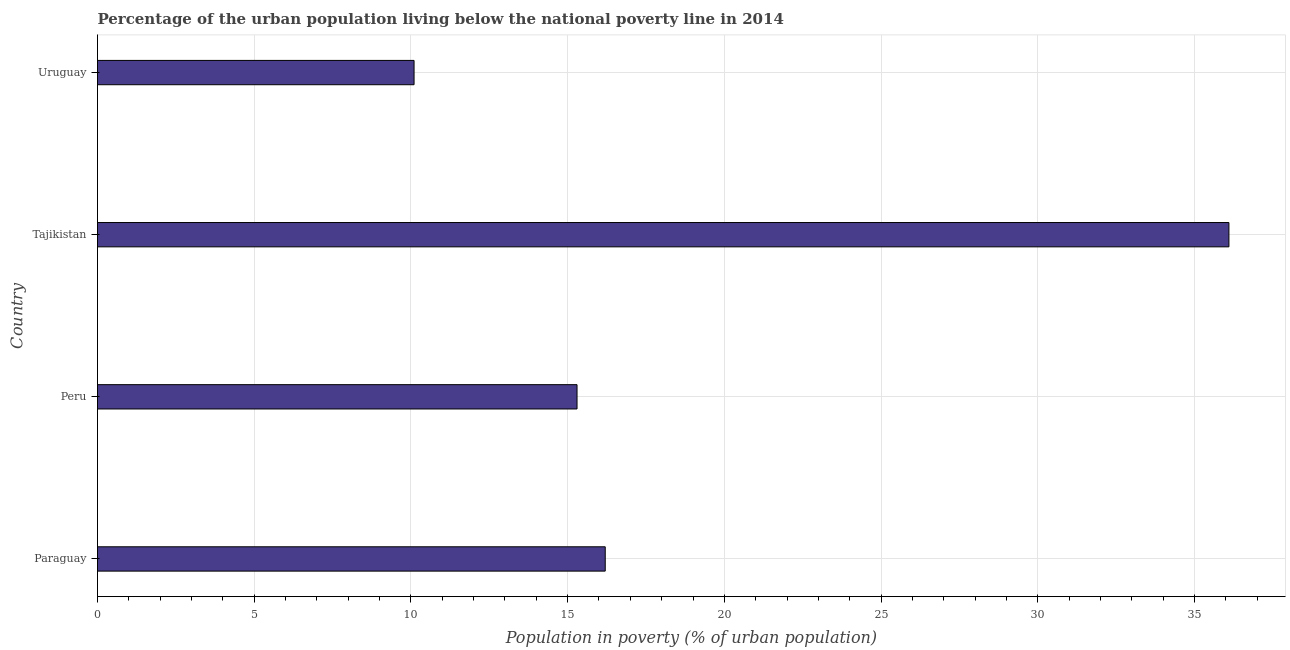Does the graph contain any zero values?
Make the answer very short. No. Does the graph contain grids?
Your answer should be very brief. Yes. What is the title of the graph?
Keep it short and to the point. Percentage of the urban population living below the national poverty line in 2014. What is the label or title of the X-axis?
Provide a succinct answer. Population in poverty (% of urban population). What is the label or title of the Y-axis?
Offer a terse response. Country. Across all countries, what is the maximum percentage of urban population living below poverty line?
Your answer should be very brief. 36.1. In which country was the percentage of urban population living below poverty line maximum?
Your answer should be very brief. Tajikistan. In which country was the percentage of urban population living below poverty line minimum?
Offer a very short reply. Uruguay. What is the sum of the percentage of urban population living below poverty line?
Offer a very short reply. 77.7. What is the difference between the percentage of urban population living below poverty line in Paraguay and Uruguay?
Provide a short and direct response. 6.1. What is the average percentage of urban population living below poverty line per country?
Provide a short and direct response. 19.43. What is the median percentage of urban population living below poverty line?
Provide a short and direct response. 15.75. In how many countries, is the percentage of urban population living below poverty line greater than 21 %?
Your answer should be very brief. 1. What is the ratio of the percentage of urban population living below poverty line in Tajikistan to that in Uruguay?
Keep it short and to the point. 3.57. Is the difference between the percentage of urban population living below poverty line in Paraguay and Uruguay greater than the difference between any two countries?
Offer a very short reply. No. What is the difference between the highest and the second highest percentage of urban population living below poverty line?
Ensure brevity in your answer.  19.9. Is the sum of the percentage of urban population living below poverty line in Tajikistan and Uruguay greater than the maximum percentage of urban population living below poverty line across all countries?
Your response must be concise. Yes. What is the difference between the highest and the lowest percentage of urban population living below poverty line?
Provide a succinct answer. 26. In how many countries, is the percentage of urban population living below poverty line greater than the average percentage of urban population living below poverty line taken over all countries?
Ensure brevity in your answer.  1. How many bars are there?
Your answer should be compact. 4. Are all the bars in the graph horizontal?
Provide a short and direct response. Yes. How many countries are there in the graph?
Provide a succinct answer. 4. Are the values on the major ticks of X-axis written in scientific E-notation?
Keep it short and to the point. No. What is the Population in poverty (% of urban population) of Tajikistan?
Make the answer very short. 36.1. What is the difference between the Population in poverty (% of urban population) in Paraguay and Tajikistan?
Offer a terse response. -19.9. What is the difference between the Population in poverty (% of urban population) in Peru and Tajikistan?
Offer a very short reply. -20.8. What is the ratio of the Population in poverty (% of urban population) in Paraguay to that in Peru?
Make the answer very short. 1.06. What is the ratio of the Population in poverty (% of urban population) in Paraguay to that in Tajikistan?
Your answer should be compact. 0.45. What is the ratio of the Population in poverty (% of urban population) in Paraguay to that in Uruguay?
Offer a terse response. 1.6. What is the ratio of the Population in poverty (% of urban population) in Peru to that in Tajikistan?
Provide a succinct answer. 0.42. What is the ratio of the Population in poverty (% of urban population) in Peru to that in Uruguay?
Make the answer very short. 1.51. What is the ratio of the Population in poverty (% of urban population) in Tajikistan to that in Uruguay?
Your response must be concise. 3.57. 